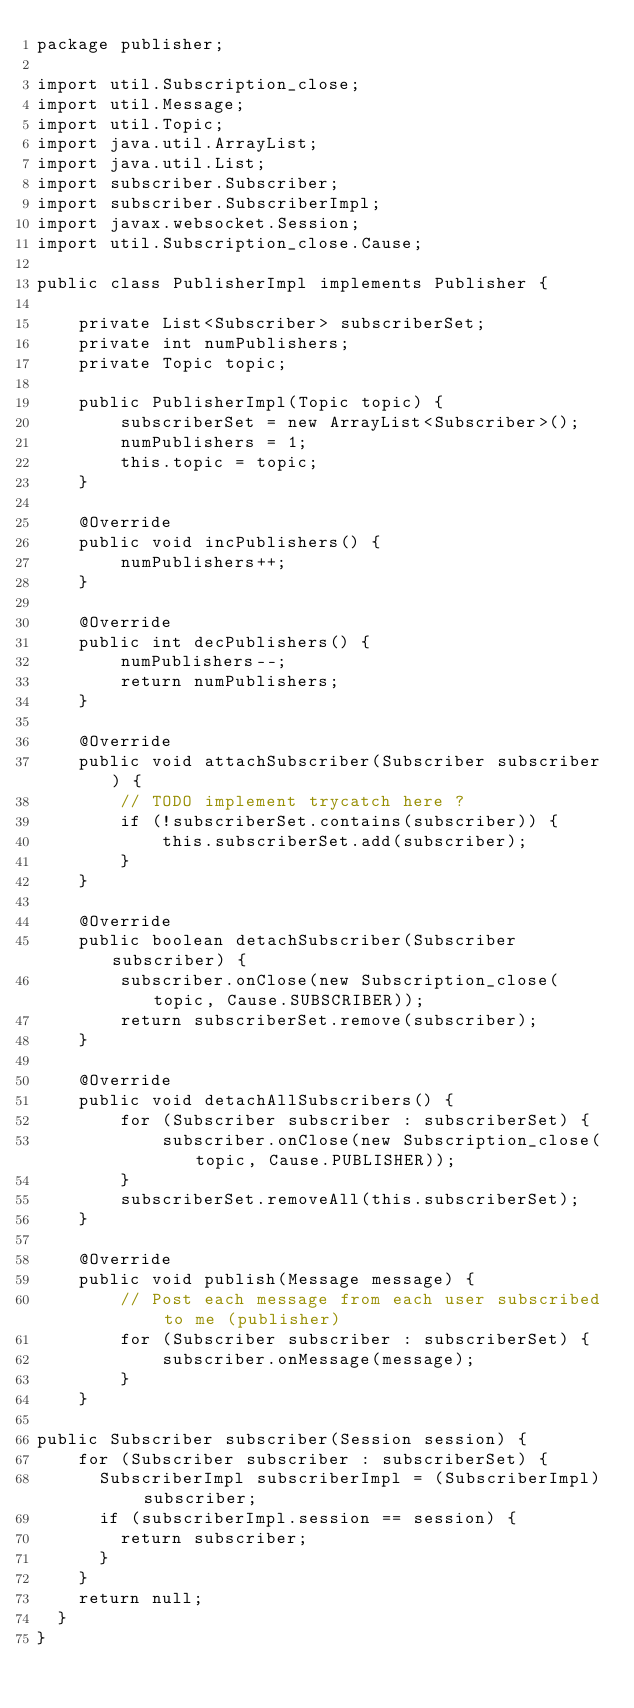Convert code to text. <code><loc_0><loc_0><loc_500><loc_500><_Java_>package publisher;

import util.Subscription_close;
import util.Message;
import util.Topic;
import java.util.ArrayList;
import java.util.List;
import subscriber.Subscriber;
import subscriber.SubscriberImpl;
import javax.websocket.Session;
import util.Subscription_close.Cause;

public class PublisherImpl implements Publisher {

    private List<Subscriber> subscriberSet;
    private int numPublishers;
    private Topic topic;

    public PublisherImpl(Topic topic) {
        subscriberSet = new ArrayList<Subscriber>();
        numPublishers = 1;
        this.topic = topic;
    }

    @Override
    public void incPublishers() {
        numPublishers++;
    }

    @Override
    public int decPublishers() {
        numPublishers--;
        return numPublishers;
    }

    @Override
    public void attachSubscriber(Subscriber subscriber) {
        // TODO implement trycatch here ?
        if (!subscriberSet.contains(subscriber)) {
            this.subscriberSet.add(subscriber);
        }
    }

    @Override
    public boolean detachSubscriber(Subscriber subscriber) {
        subscriber.onClose(new Subscription_close(topic, Cause.SUBSCRIBER));
        return subscriberSet.remove(subscriber);
    }

    @Override
    public void detachAllSubscribers() {
        for (Subscriber subscriber : subscriberSet) {
            subscriber.onClose(new Subscription_close(topic, Cause.PUBLISHER));
        }
        subscriberSet.removeAll(this.subscriberSet);
    }

    @Override
    public void publish(Message message) {
        // Post each message from each user subscribed to me (publisher)
        for (Subscriber subscriber : subscriberSet) {
            subscriber.onMessage(message);
        }
    }

public Subscriber subscriber(Session session) {
    for (Subscriber subscriber : subscriberSet) {
      SubscriberImpl subscriberImpl = (SubscriberImpl) subscriber;
      if (subscriberImpl.session == session) {
        return subscriber;
      }
    }
    return null;
  }
}
</code> 